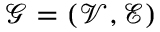Convert formula to latex. <formula><loc_0><loc_0><loc_500><loc_500>\mathcal { G } = ( \mathcal { V } , \mathcal { E } )</formula> 